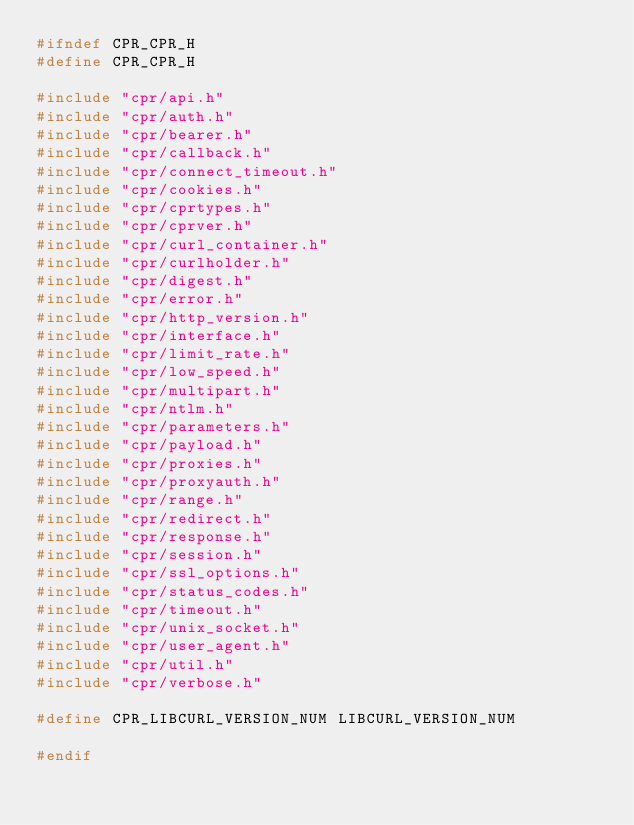<code> <loc_0><loc_0><loc_500><loc_500><_C_>#ifndef CPR_CPR_H
#define CPR_CPR_H

#include "cpr/api.h"
#include "cpr/auth.h"
#include "cpr/bearer.h"
#include "cpr/callback.h"
#include "cpr/connect_timeout.h"
#include "cpr/cookies.h"
#include "cpr/cprtypes.h"
#include "cpr/cprver.h"
#include "cpr/curl_container.h"
#include "cpr/curlholder.h"
#include "cpr/digest.h"
#include "cpr/error.h"
#include "cpr/http_version.h"
#include "cpr/interface.h"
#include "cpr/limit_rate.h"
#include "cpr/low_speed.h"
#include "cpr/multipart.h"
#include "cpr/ntlm.h"
#include "cpr/parameters.h"
#include "cpr/payload.h"
#include "cpr/proxies.h"
#include "cpr/proxyauth.h"
#include "cpr/range.h"
#include "cpr/redirect.h"
#include "cpr/response.h"
#include "cpr/session.h"
#include "cpr/ssl_options.h"
#include "cpr/status_codes.h"
#include "cpr/timeout.h"
#include "cpr/unix_socket.h"
#include "cpr/user_agent.h"
#include "cpr/util.h"
#include "cpr/verbose.h"

#define CPR_LIBCURL_VERSION_NUM LIBCURL_VERSION_NUM

#endif
</code> 